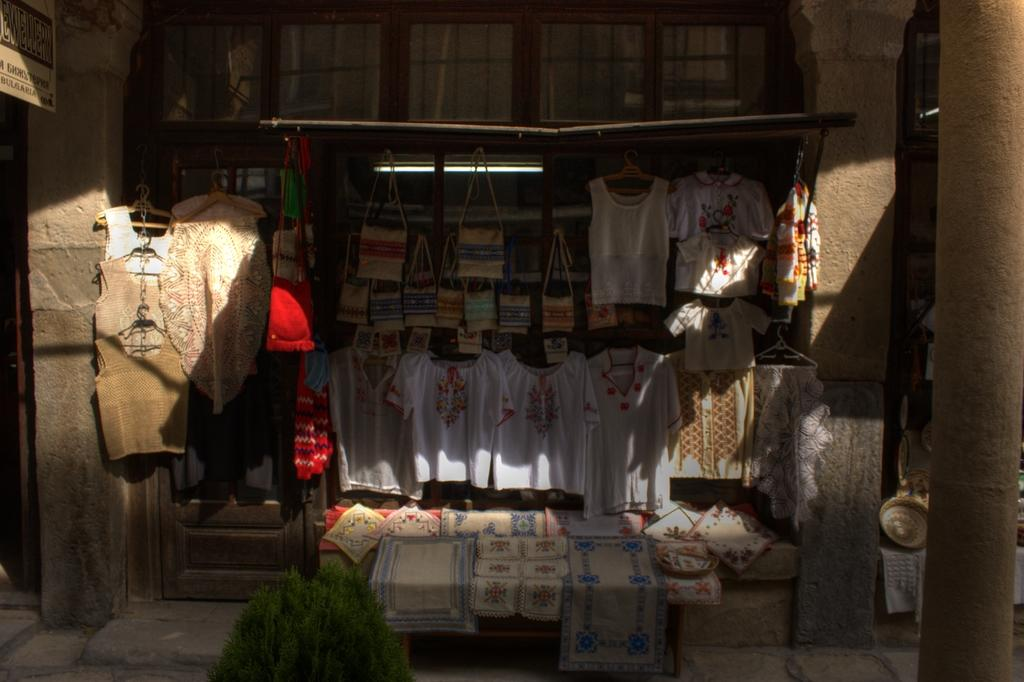What objects are present in the image? There are clothes, a plant, a pillar, and a light in the image. Where is the plant located in the image? The plant is at the bottom of the image. What is on the right side of the image? There is a pillar on the right side of the image. What is in the middle of the image? There is a light in the middle of the image. What scent can be detected from the country depicted in the image? There is no country depicted in the image, and therefore no scent can be associated with it. 